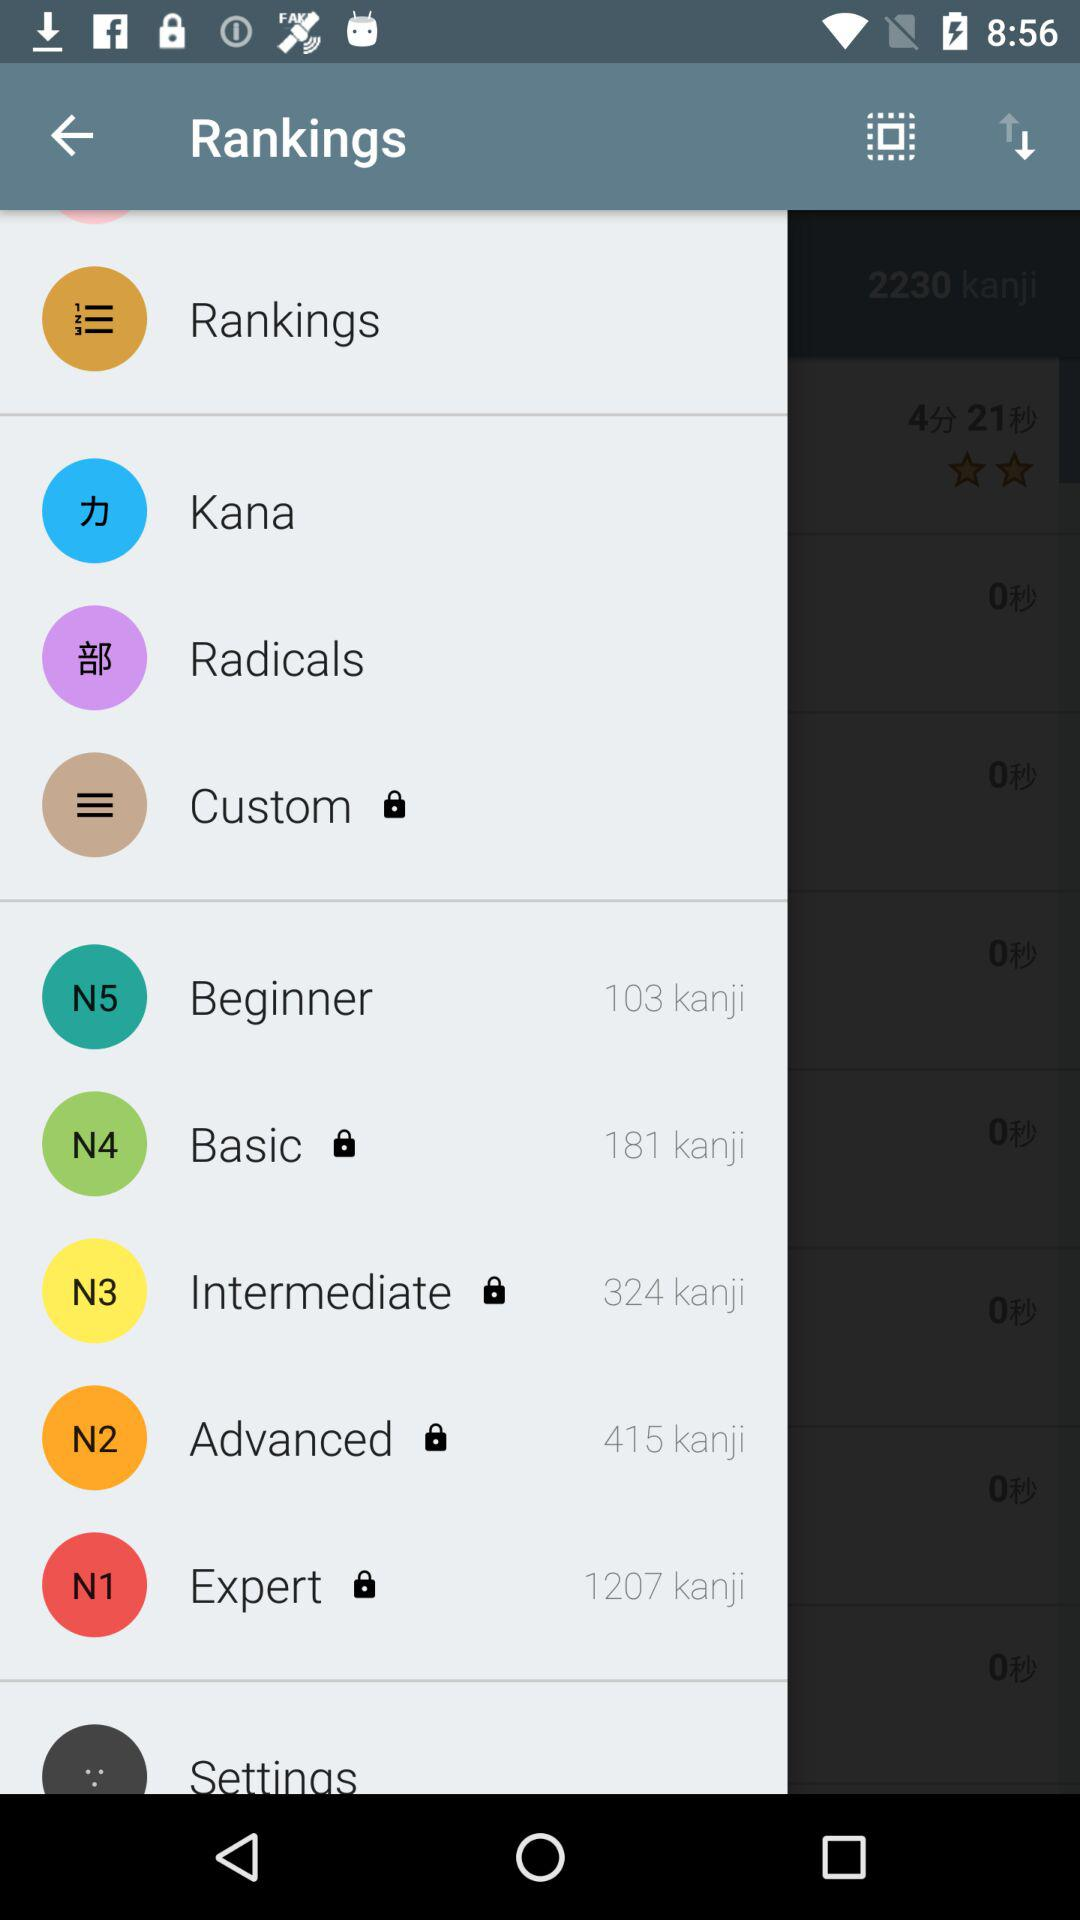Who has the maximum kanji?
When the provided information is insufficient, respond with <no answer>. <no answer> 